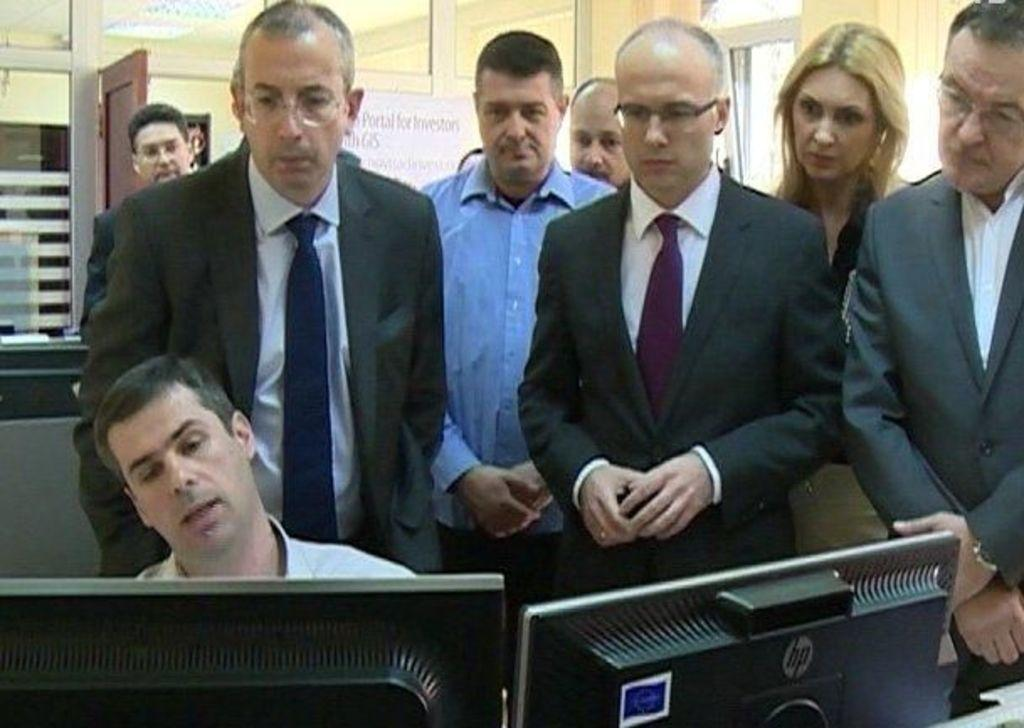What is the man in the image doing? The man is sitting on the left side of the image. What is in front of the man? There are computers in front of the man. What can be seen in the background of the image? There are people standing, a door, a board, and a wall visible in the background. What type of pies is the man eating in the image? There are no pies present in the image; the man is sitting in front of computers. 